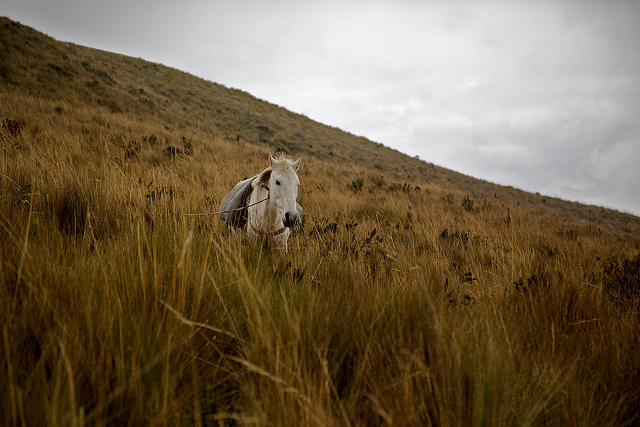<image>What brand typically uses this animal in its advertisements? I don't know what brand typically uses this animal in its advertisements. However, it could be budweiser, trojan, mustang, marlboro, or levi's. What brand typically uses this animal in its advertisements? I'm not sure which brand typically uses this animal in its advertisements. However, it could be Budweiser, Trojan, Mustang, Marlboro, Levi's, or Clint Eastwood. 